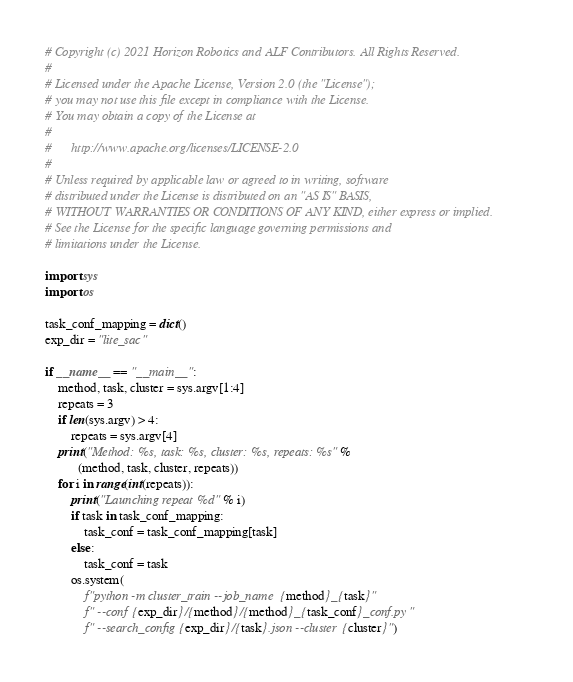Convert code to text. <code><loc_0><loc_0><loc_500><loc_500><_Python_># Copyright (c) 2021 Horizon Robotics and ALF Contributors. All Rights Reserved.
#
# Licensed under the Apache License, Version 2.0 (the "License");
# you may not use this file except in compliance with the License.
# You may obtain a copy of the License at
#
#      http://www.apache.org/licenses/LICENSE-2.0
#
# Unless required by applicable law or agreed to in writing, software
# distributed under the License is distributed on an "AS IS" BASIS,
# WITHOUT WARRANTIES OR CONDITIONS OF ANY KIND, either express or implied.
# See the License for the specific language governing permissions and
# limitations under the License.

import sys
import os

task_conf_mapping = dict()
exp_dir = "lite_sac"

if __name__ == "__main__":
    method, task, cluster = sys.argv[1:4]
    repeats = 3
    if len(sys.argv) > 4:
        repeats = sys.argv[4]
    print("Method: %s, task: %s, cluster: %s, repeats: %s" %
          (method, task, cluster, repeats))
    for i in range(int(repeats)):
        print("Launching repeat %d" % i)
        if task in task_conf_mapping:
            task_conf = task_conf_mapping[task]
        else:
            task_conf = task
        os.system(
            f"python -m cluster_train --job_name {method}_{task}"
            f" --conf {exp_dir}/{method}/{method}_{task_conf}_conf.py"
            f" --search_config {exp_dir}/{task}.json --cluster {cluster}")
</code> 